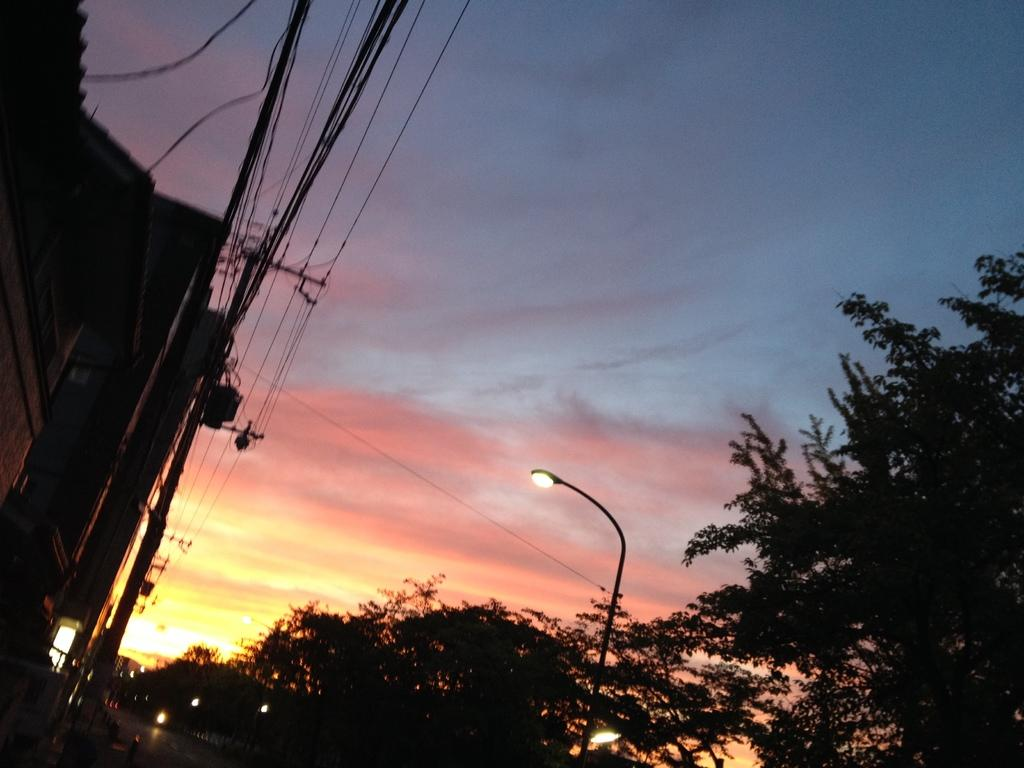What type of natural elements can be seen in the image? There are trees in the image. What type of man-made structures are present in the image? There are poles, lights, buildings, and a road in the image. What other objects can be seen in the image? There are wires in the image. What is visible in the background of the image? The sky is visible in the background of the image. What type of brass instrument is being played by the trees in the image? There is no brass instrument present in the image, as it features trees, poles, lights, buildings, a road, wires, and the sky. How does the fear of heights affect the trees in the image? There is no fear of heights present in the image, as it features trees, poles, lights, buildings, a road, wires, and the sky. 